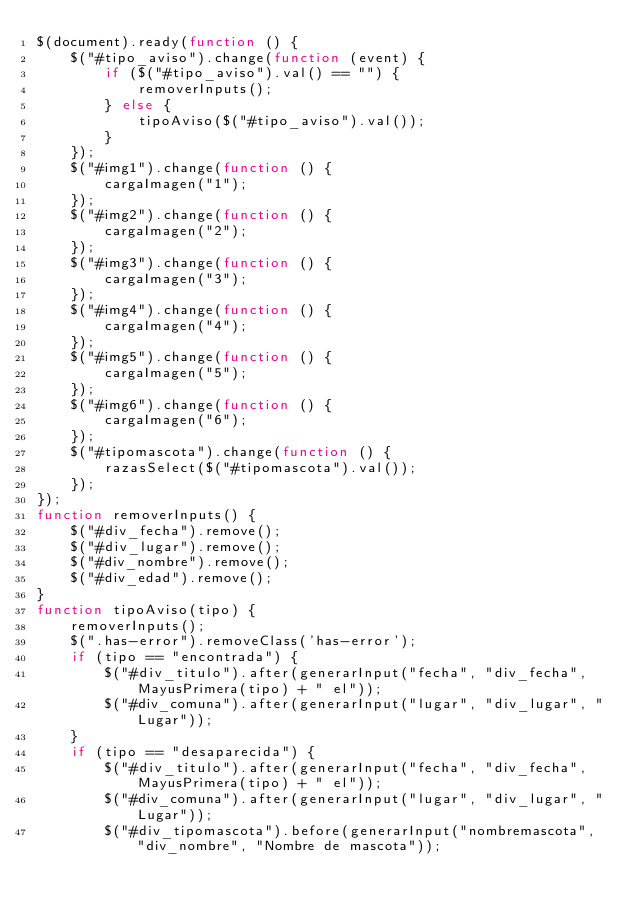Convert code to text. <code><loc_0><loc_0><loc_500><loc_500><_JavaScript_>$(document).ready(function () {
    $("#tipo_aviso").change(function (event) {
        if ($("#tipo_aviso").val() == "") {
            removerInputs();
        } else {
            tipoAviso($("#tipo_aviso").val());
        }
    });
    $("#img1").change(function () {
        cargaImagen("1");
    });
    $("#img2").change(function () {
        cargaImagen("2");
    });
    $("#img3").change(function () {
        cargaImagen("3");
    });
    $("#img4").change(function () {
        cargaImagen("4");
    });
    $("#img5").change(function () {
        cargaImagen("5");
    });
    $("#img6").change(function () {
        cargaImagen("6");
    });
    $("#tipomascota").change(function () {
        razasSelect($("#tipomascota").val());
    });
});
function removerInputs() {
    $("#div_fecha").remove();
    $("#div_lugar").remove();
    $("#div_nombre").remove();
    $("#div_edad").remove();
}
function tipoAviso(tipo) {
    removerInputs();
    $(".has-error").removeClass('has-error');
    if (tipo == "encontrada") {
        $("#div_titulo").after(generarInput("fecha", "div_fecha", MayusPrimera(tipo) + " el"));
        $("#div_comuna").after(generarInput("lugar", "div_lugar", "Lugar"));
    }
    if (tipo == "desaparecida") {
        $("#div_titulo").after(generarInput("fecha", "div_fecha", MayusPrimera(tipo) + " el"));
        $("#div_comuna").after(generarInput("lugar", "div_lugar", "Lugar"));
        $("#div_tipomascota").before(generarInput("nombremascota", "div_nombre", "Nombre de mascota"));</code> 